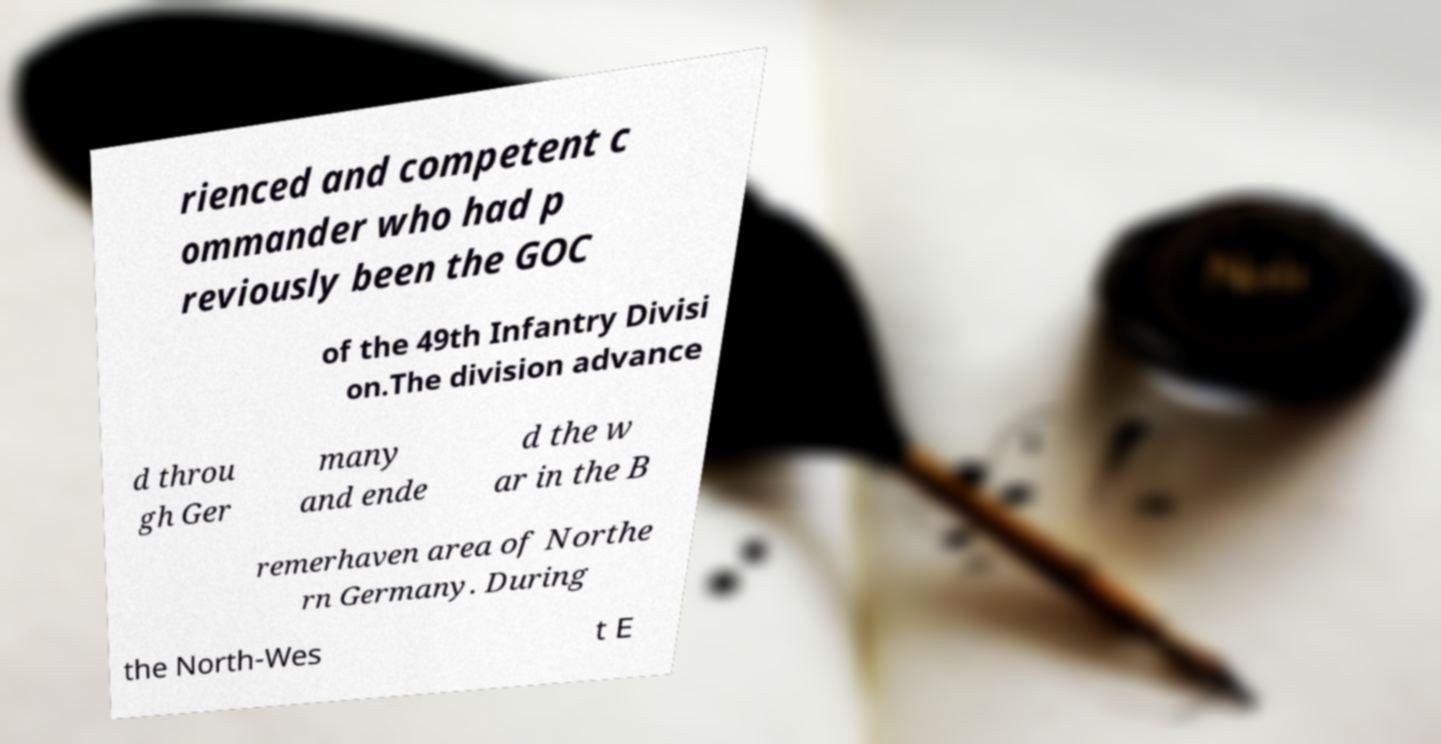Please identify and transcribe the text found in this image. rienced and competent c ommander who had p reviously been the GOC of the 49th Infantry Divisi on.The division advance d throu gh Ger many and ende d the w ar in the B remerhaven area of Northe rn Germany. During the North-Wes t E 